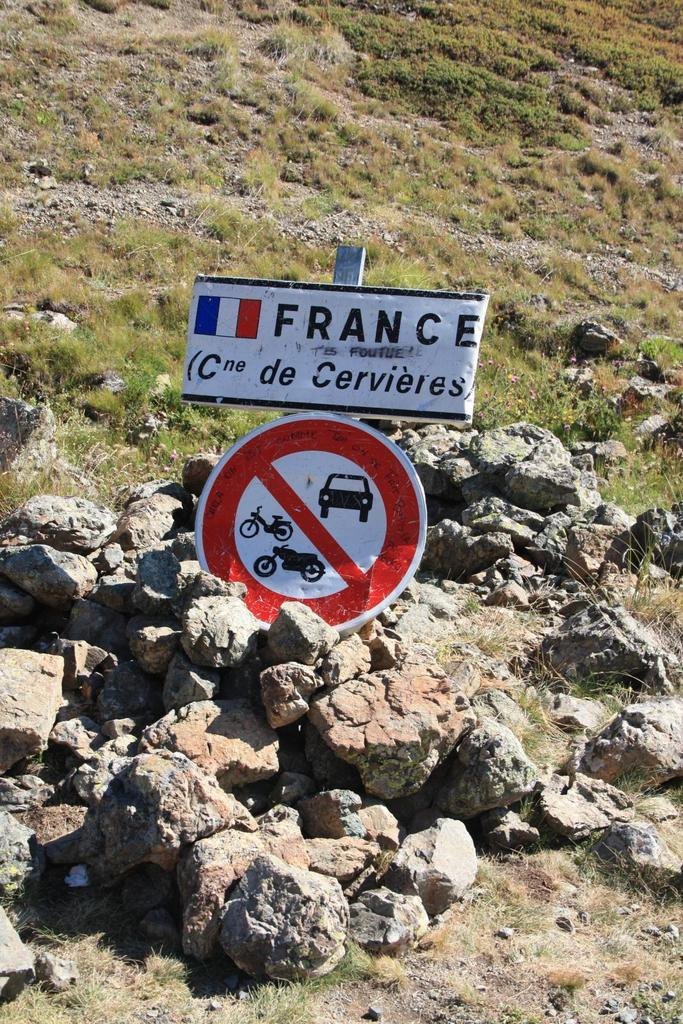<image>
Give a short and clear explanation of the subsequent image. a sign that says France also says no cars or motorbikes 